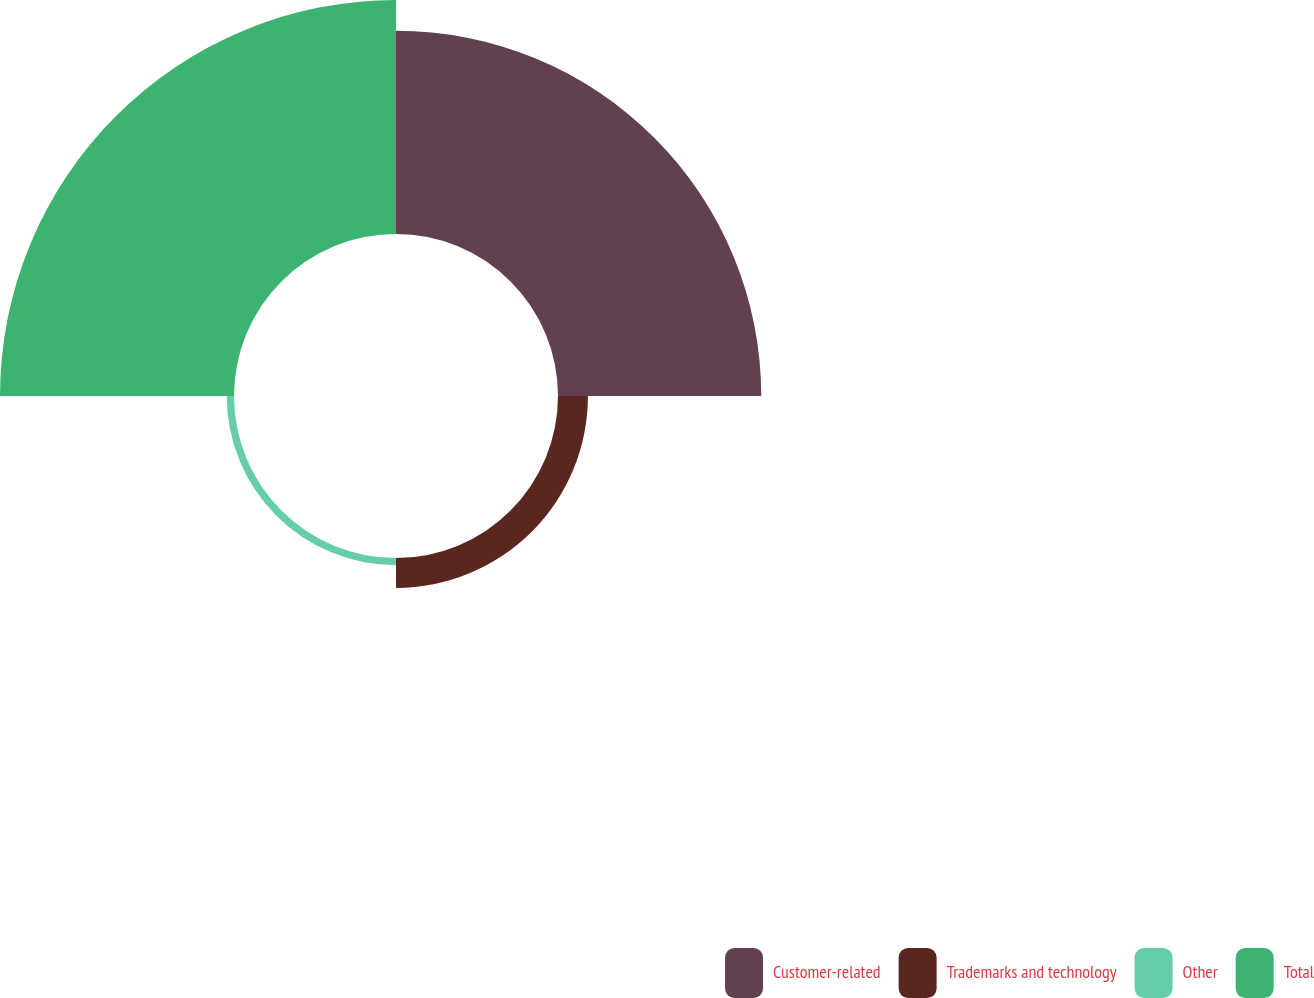<chart> <loc_0><loc_0><loc_500><loc_500><pie_chart><fcel>Customer-related<fcel>Trademarks and technology<fcel>Other<fcel>Total<nl><fcel>42.84%<fcel>6.31%<fcel>1.53%<fcel>49.32%<nl></chart> 